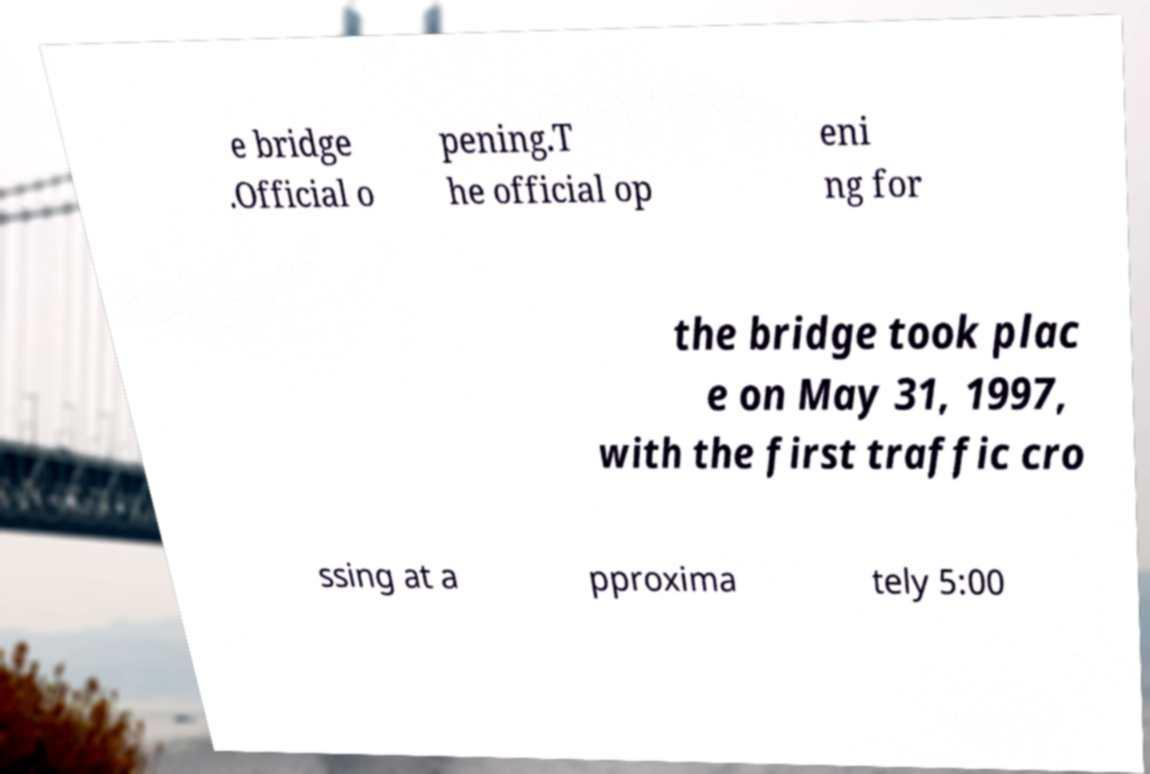There's text embedded in this image that I need extracted. Can you transcribe it verbatim? e bridge .Official o pening.T he official op eni ng for the bridge took plac e on May 31, 1997, with the first traffic cro ssing at a pproxima tely 5:00 